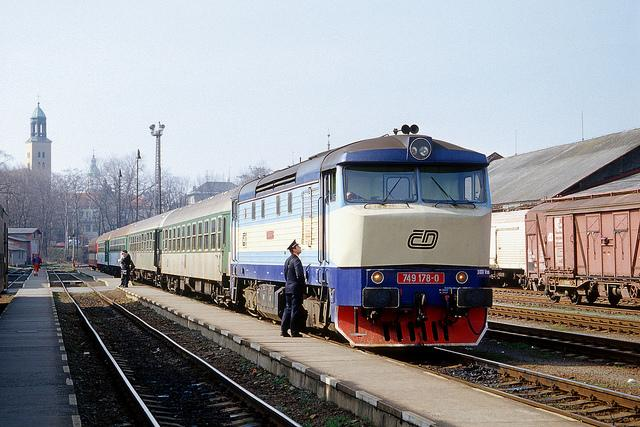What does this vehicle travel on? Please explain your reasoning. rails. This vehicle is a train, not an airplane, car, or boat. 